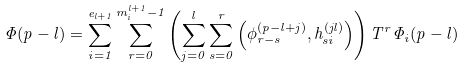Convert formula to latex. <formula><loc_0><loc_0><loc_500><loc_500>\Phi ( p - l ) = \sum _ { i = 1 } ^ { e _ { l + 1 } } \sum _ { r = 0 } ^ { m _ { i } ^ { l + 1 } - 1 } \left ( \sum _ { j = 0 } ^ { l } \sum _ { s = 0 } ^ { r } \left ( \phi _ { r - s } ^ { ( p - l + j ) } , h _ { s i } ^ { ( j l ) } \right ) \right ) T ^ { r } \Phi _ { i } ( p - l )</formula> 